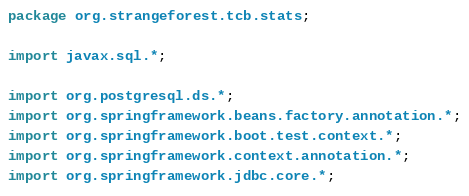<code> <loc_0><loc_0><loc_500><loc_500><_Java_>package org.strangeforest.tcb.stats;

import javax.sql.*;

import org.postgresql.ds.*;
import org.springframework.beans.factory.annotation.*;
import org.springframework.boot.test.context.*;
import org.springframework.context.annotation.*;
import org.springframework.jdbc.core.*;</code> 